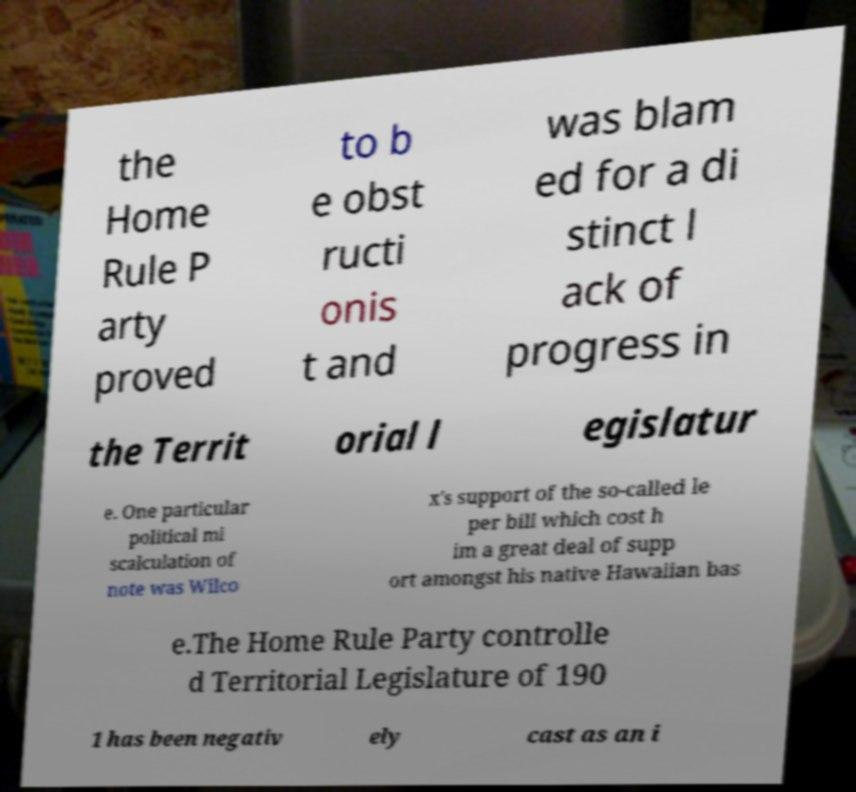For documentation purposes, I need the text within this image transcribed. Could you provide that? the Home Rule P arty proved to b e obst ructi onis t and was blam ed for a di stinct l ack of progress in the Territ orial l egislatur e. One particular political mi scalculation of note was Wilco x's support of the so-called le per bill which cost h im a great deal of supp ort amongst his native Hawaiian bas e.The Home Rule Party controlle d Territorial Legislature of 190 1 has been negativ ely cast as an i 